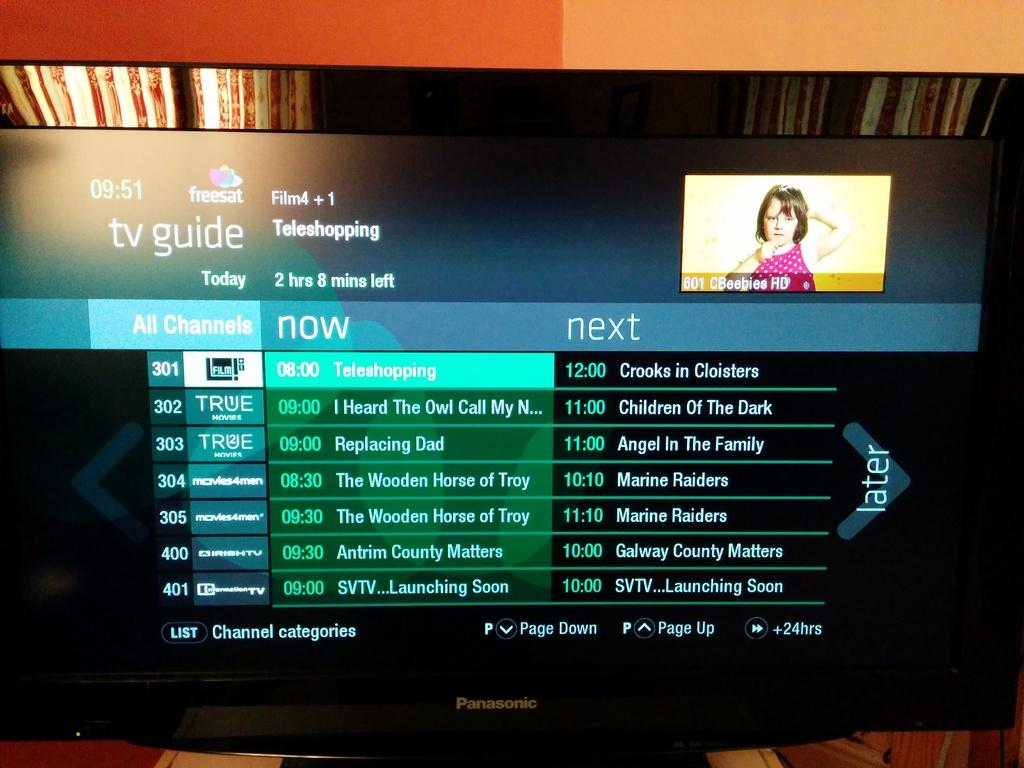What is the main object in the image? There is a screen in the image. What can be seen on the screen? A girl is visible on the screen. What else is visible on the screen besides the girl? There is some information visible on the screen. How many mountains can be seen in the image? There are no mountains visible in the image; it features a screen with a girl and some information. Is there a table and lamp present in the image? There is no table or lamp present in the image; it only features a screen. 